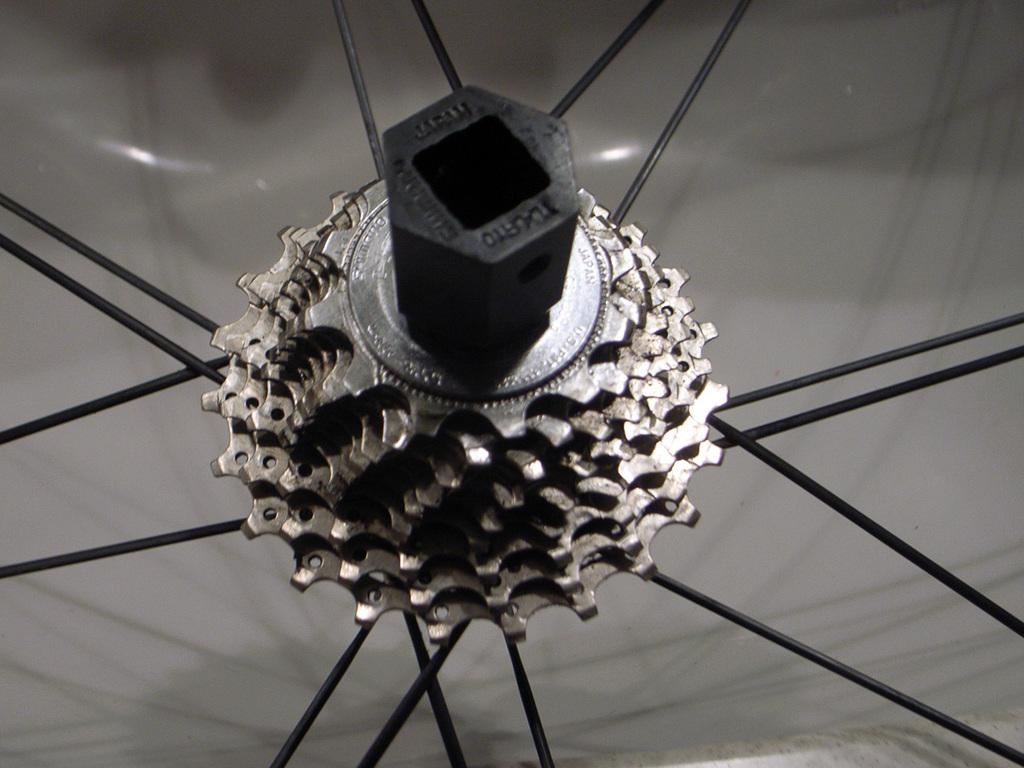What mechanical components can be seen in the image? There are gears and spokes in the image. What type of animals can be seen at the zoo in the image? There is no zoo present in the image, and therefore no animals can be observed. What type of skin condition is visible on the governor in the image? There is no governor or skin condition present in the image. 